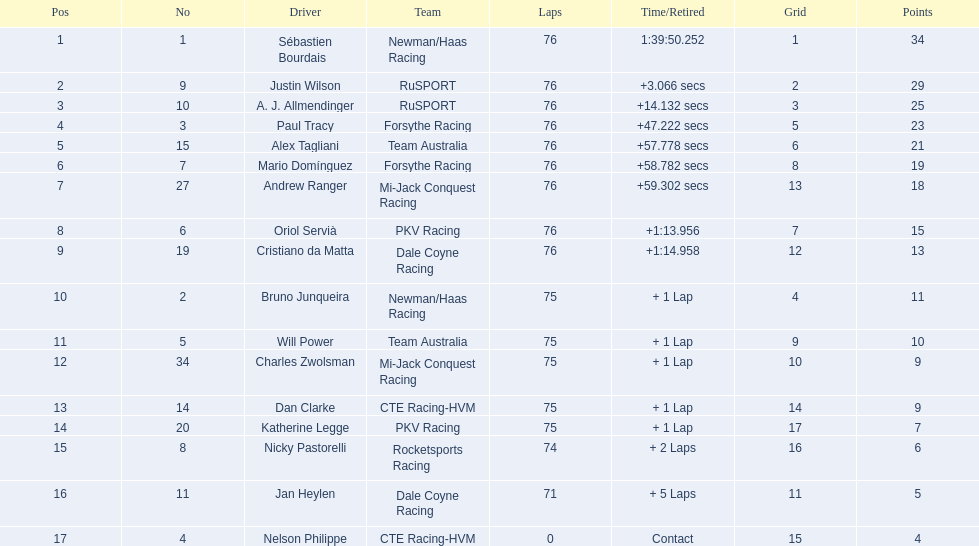Which drivers managed to complete all 76 laps? Sébastien Bourdais, Justin Wilson, A. J. Allmendinger, Paul Tracy, Alex Tagliani, Mario Domínguez, Andrew Ranger, Oriol Servià, Cristiano da Matta. Of these drivers, which ones were less than a minute behind the winner? Paul Tracy, Alex Tagliani, Mario Domínguez, Andrew Ranger. Of these drivers, which ones had a time less than 50 seconds behind the first place? Justin Wilson, A. J. Allmendinger, Paul Tracy. Of these three drivers, who ended up last? Paul Tracy. 